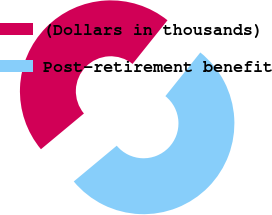<chart> <loc_0><loc_0><loc_500><loc_500><pie_chart><fcel>(Dollars in thousands)<fcel>Post-retirement benefit<nl><fcel>46.79%<fcel>53.21%<nl></chart> 